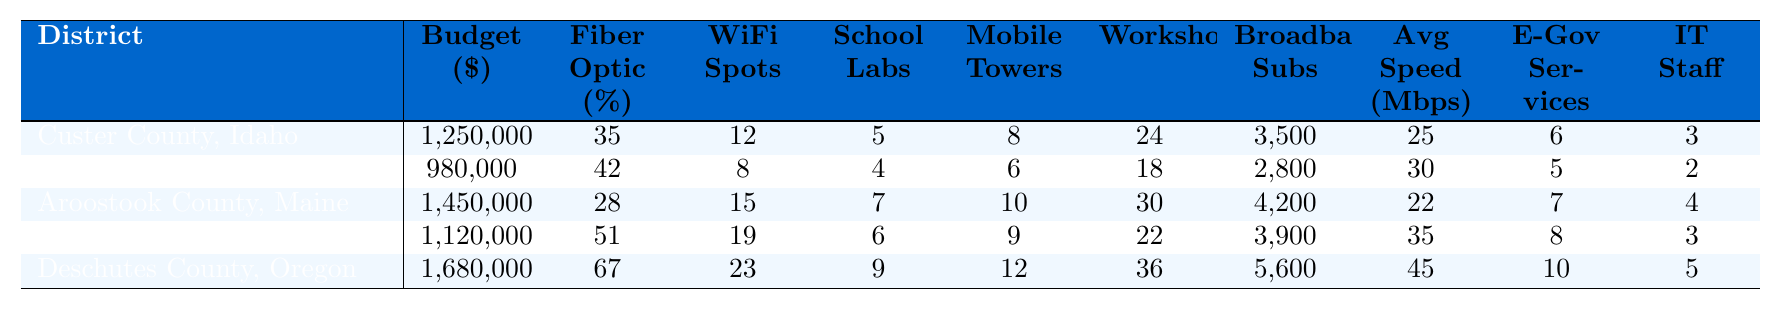What is the total budget allocated for digital infrastructure projects across all districts? Sum the budget allocations: 1,250,000 + 980,000 + 1,450,000 + 1,120,000 + 1,680,000 = 6,480,000.
Answer: 6,480,000 Which district has the highest fiber optic coverage percentage? Look through the fiber optic coverage percentages: Custer County (35%), Franklin County (42%), Aroostook County (28%), Marquette County (51%), Deschutes County (67%). Deschutes County has the highest percentage at 67%.
Answer: Deschutes County, Oregon How many public WiFi hotspots are available in Marquette County, Michigan? Check the public WiFi hotspots column for Marquette County: It shows 19 hotspots.
Answer: 19 What is the average number of computer labs in schools across all districts? Calculate the average by summing the computer lab counts: (5 + 4 + 7 + 6 + 9) = 31. Then, divide by the number of districts (5): 31 / 5 = 6.2.
Answer: 6.2 True or False: Aroostook County, Maine has more broadband subscribers than Franklin County, Vermont. Compare the broadband subscribers: Aroostook County has 4,200 and Franklin County has 2,800, thus Aroostook County does have more.
Answer: True What is the difference in the number of digital literacy workshops between Deschutes County, Oregon and Aroostook County, Maine? Find the workshops numbers: Deschutes County has 36 and Aroostook County has 30. The difference is 36 - 30 = 6.
Answer: 6 Which district has the highest number of mobile internet towers? Check the mobile internet towers column: Custer County (8), Franklin County (6), Aroostook County (10), Marquette County (9), Deschutes County (12). Deschutes County has the highest at 12 towers.
Answer: Deschutes County, Oregon What is the median average internet speed in the districts listed? First, list the speeds: 25, 30, 22, 35, 45. Sort the list: 22, 25, 30, 35, 45. The median is the middle value: 30.
Answer: 30 How many more e-government services are available in Deschutes County, Oregon than in Franklin County, Vermont? Determine the number of services: Deschutes County has 10 and Franklin County has 5. The difference is 10 - 5 = 5.
Answer: 5 Which district has the lowest budget allocation and what is that amount? Review the budget allocations: Custer County (1,250,000), Franklin County (980,000), Aroostook County (1,450,000), Marquette County (1,120,000), Deschutes County (1,680,000). Franklin County has the lowest allocation of 980,000.
Answer: Franklin County, Vermont; 980,000 